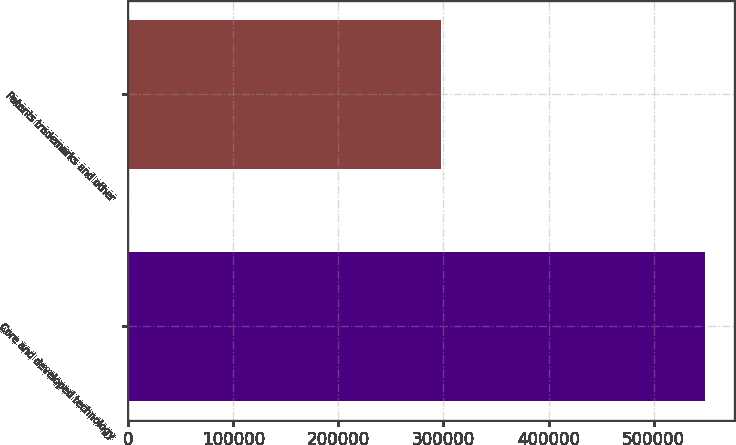Convert chart. <chart><loc_0><loc_0><loc_500><loc_500><bar_chart><fcel>Core and developed technology<fcel>Patents trademarks and other<nl><fcel>548974<fcel>297321<nl></chart> 